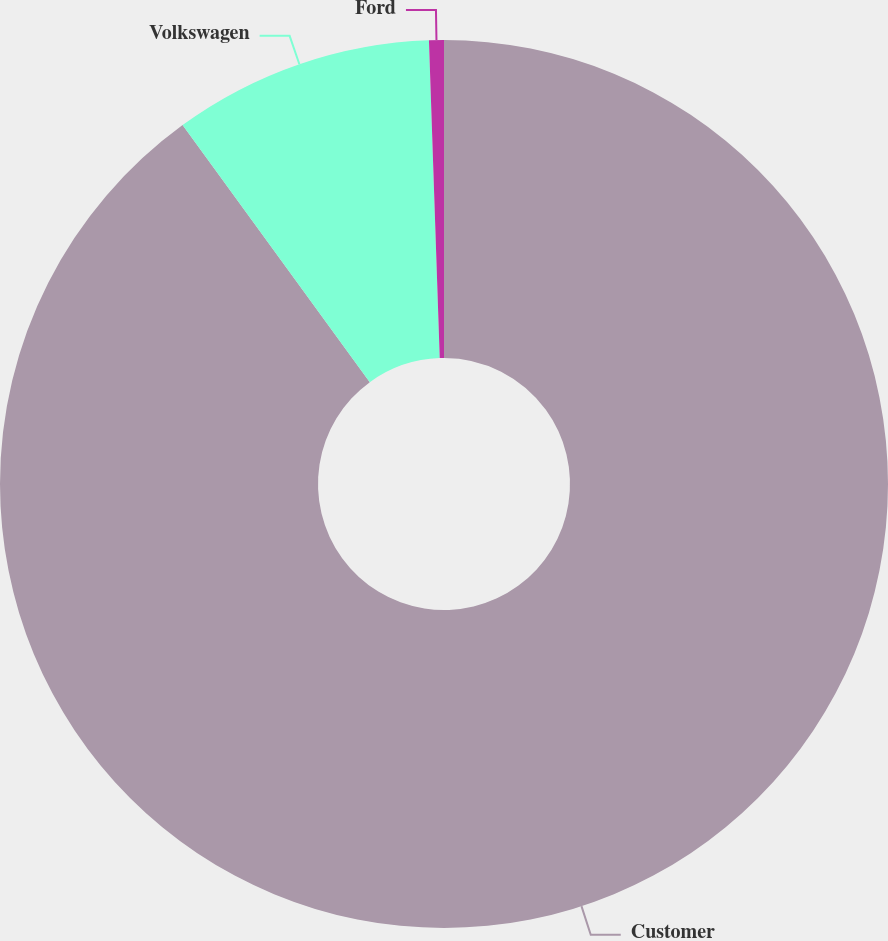Convert chart to OTSL. <chart><loc_0><loc_0><loc_500><loc_500><pie_chart><fcel>Customer<fcel>Volkswagen<fcel>Ford<nl><fcel>89.98%<fcel>9.48%<fcel>0.54%<nl></chart> 